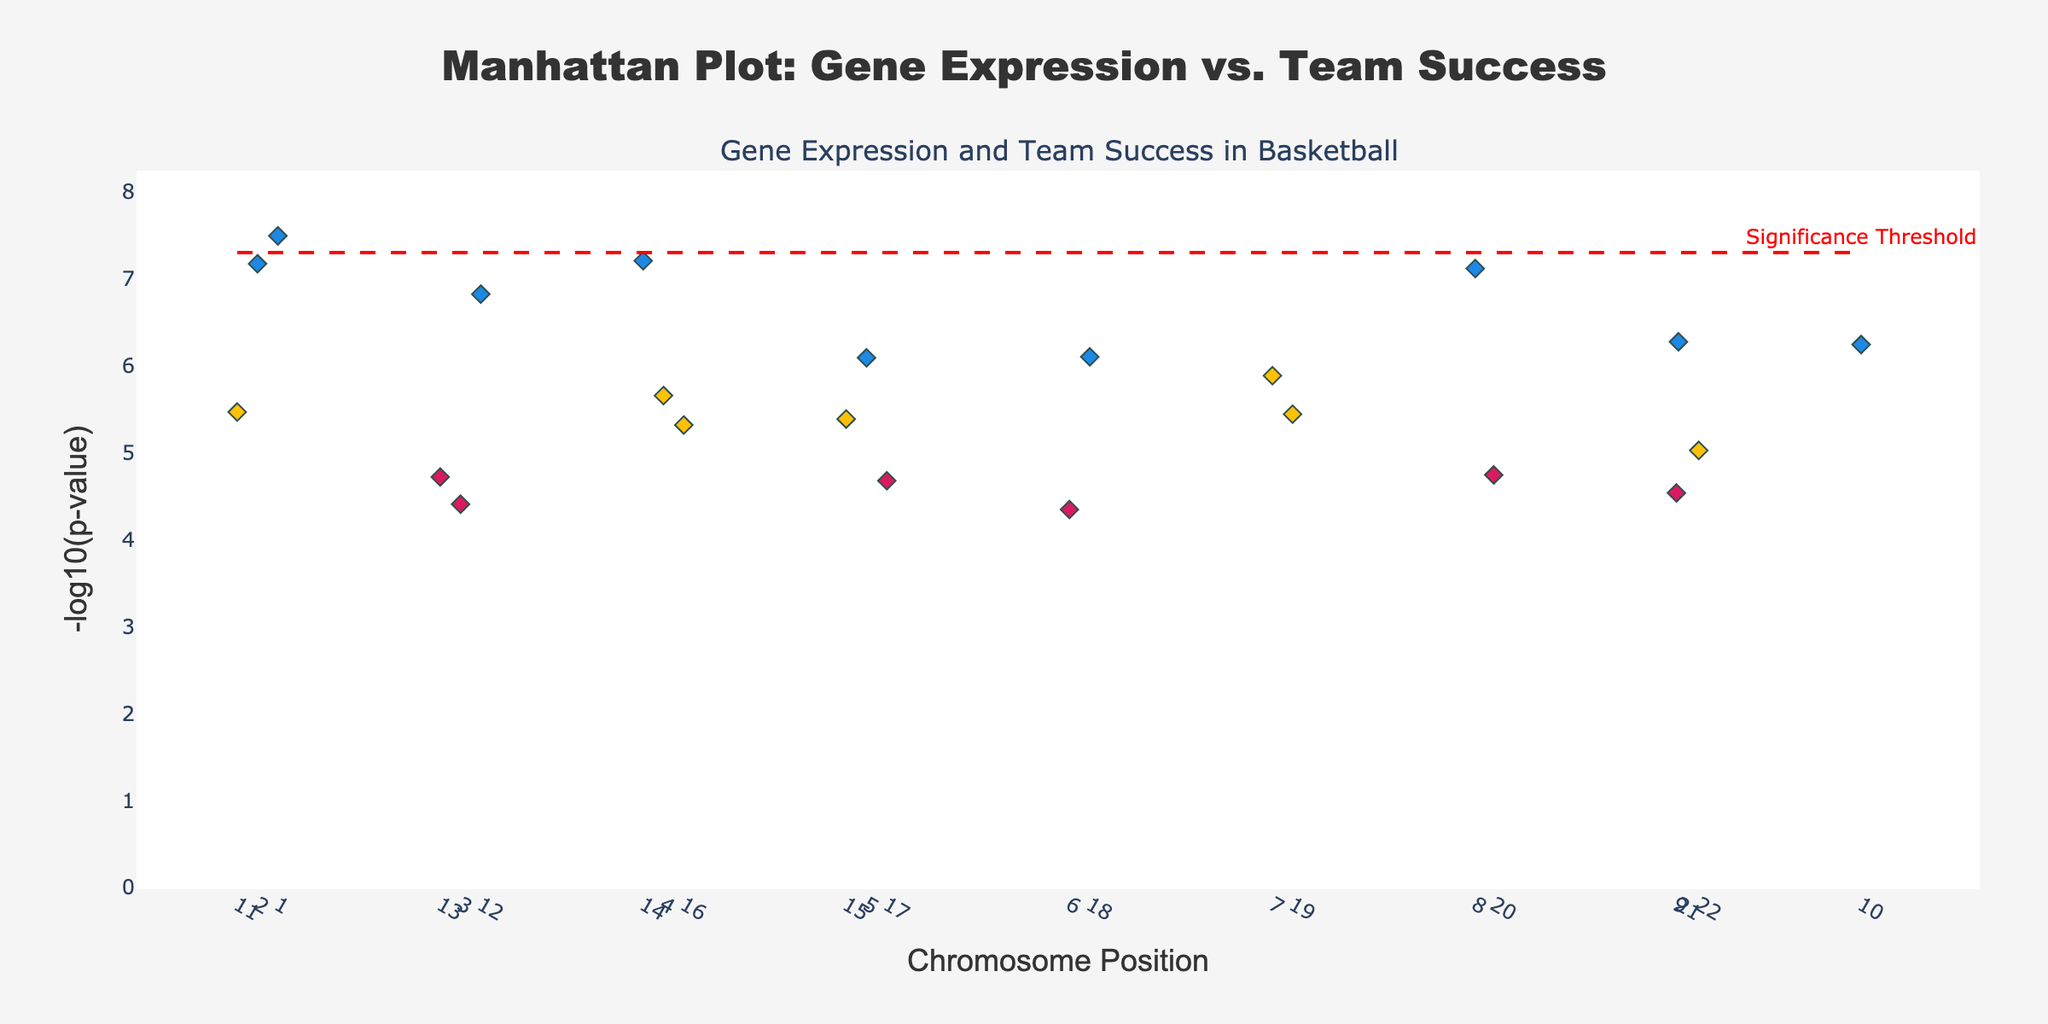What is the title of the plot? The title is usually located at the top center of the plot, displaying the main subject of the visualized data. The title of this plot is 'Manhattan Plot: Gene Expression vs. Team Success'.
Answer: Manhattan Plot: Gene Expression vs. Team Success What are the axes labels in the plot? Axes labels typically describe what is measured on each axis. The x-axis is labeled 'Chromosome Position', and the y-axis is labeled '-log10(p-value)'.
Answer: Chromosome Position, -log10(p-value) How many data points are associated with 'High' team success? Each data point is a diamond marker color-coded to represent different team success levels. By counting the blue diamond markers, we find there are 9 data points associated with 'High' team success.
Answer: 9 What does the red dashed line represent? The red dashed line corresponds to a significance threshold commonly used in Manhattan Plots, here indicated by the annotation 'Significance Threshold'.
Answer: Significance Threshold Which chromosome contains the gene with the highest -log10(p-value) for 'High' team success? Scanning from left to right and referencing the y-axis, the gene with the highest -log10(p-value) for 'High' team success is 'OXTR' on chromosome 1.
Answer: Chromosome 1 What is the range of -log10(p-value) displayed on the y-axis? The range on the y-axis starts at 0 and extends to slightly above the maximum -log10(p-value) of the data points, which is around 7.5. This range is adjusted to fit the highest values comfortably.
Answer: 0 to around 7.5 Which gene has the lowest p-value, and what is its team success level? The gene with the lowest p-value will have the highest -log10(p-value). By identifying the peak point in the plot, we see 'OXTR' gene has the lowest p-value. Its team success level is 'High'.
Answer: OXTR, High How many genes are above the significance threshold? Observing the number of data points positioned above the red dashed significance line can tell us how many genes are significant. By counting, we note that there are 6 genes above this threshold.
Answer: 6 Which gene corresponds to a 'Moderate' team success level and has a p-value of exactly 2.2e-6? Identifying the gene with a specific p-value and team success level requires examining the markers colored yellow (Moderate) and locating the gene with the p-value of 2.2e-6. The gene is 'CRHR1'.
Answer: CRHR1 Compare the number of significant genes between 'High' and 'Moderate' team success levels. Which group has more? Count the number of points above the significance threshold for both blue (High) and yellow (Moderate). 'High' has 6 points, while 'Moderate' has 0. Therefore, 'High' has more significant genes.
Answer: High has more 